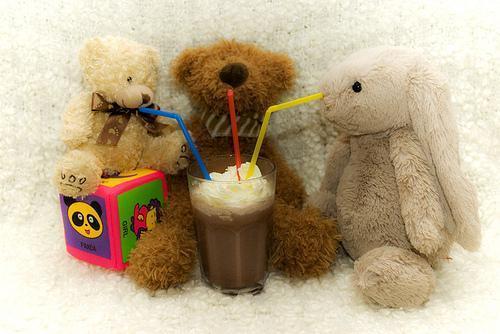How many stuffed animals are shown?
Give a very brief answer. 3. How many straws are shown?
Give a very brief answer. 3. How many light brown bears?
Give a very brief answer. 1. How many straws?
Give a very brief answer. 3. How many friends are drinking shake?
Give a very brief answer. 3. 